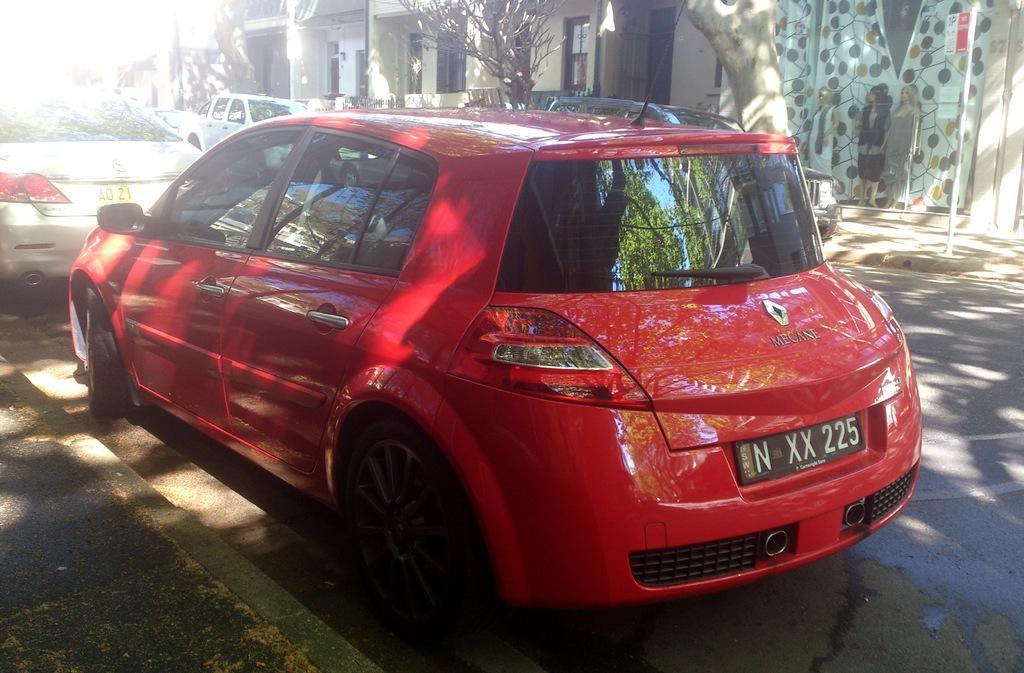Describe this image in one or two sentences. In the center of the image we can see cars on the road. In the background we can see trees and buildings. 